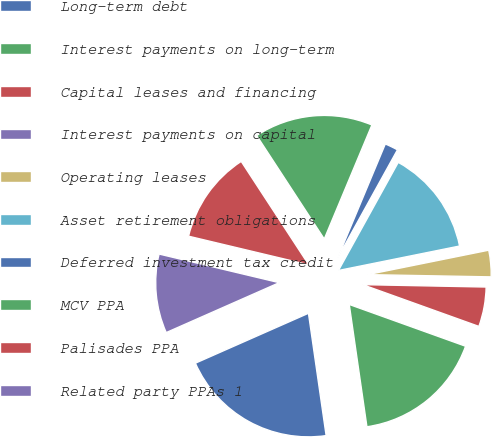<chart> <loc_0><loc_0><loc_500><loc_500><pie_chart><fcel>Long-term debt<fcel>Interest payments on long-term<fcel>Capital leases and financing<fcel>Interest payments on capital<fcel>Operating leases<fcel>Asset retirement obligations<fcel>Deferred investment tax credit<fcel>MCV PPA<fcel>Palisades PPA<fcel>Related party PPAs 1<nl><fcel>20.67%<fcel>17.23%<fcel>5.18%<fcel>0.02%<fcel>3.46%<fcel>13.79%<fcel>1.74%<fcel>15.51%<fcel>12.07%<fcel>10.34%<nl></chart> 